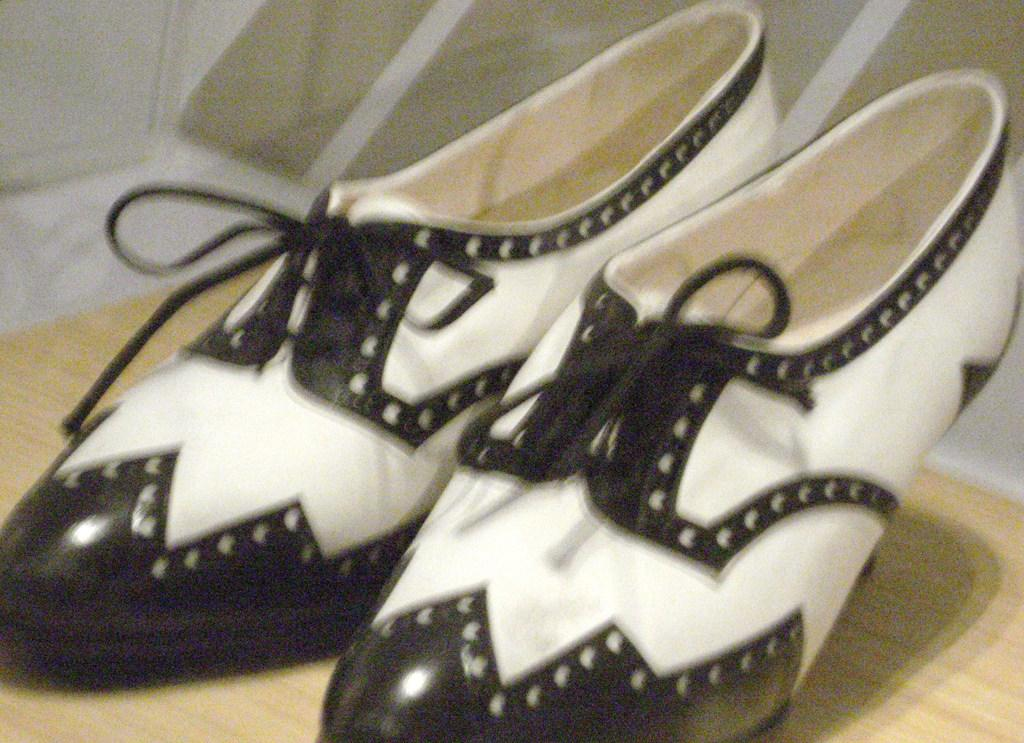What type of footwear is visible in the image? There is footwear in the image, and it is in black and white color. What else can be seen in the image besides the footwear? There is a wall in the image. What type of nose can be seen on the footwear in the image? There is no nose present on the footwear in the image, as it is not a living organism. What type of wire is connected to the footwear in the image? There is no wire connected to the footwear in the image. What type of crown is placed on top of the footwear in the image? There is no crown present on the footwear in the image. 